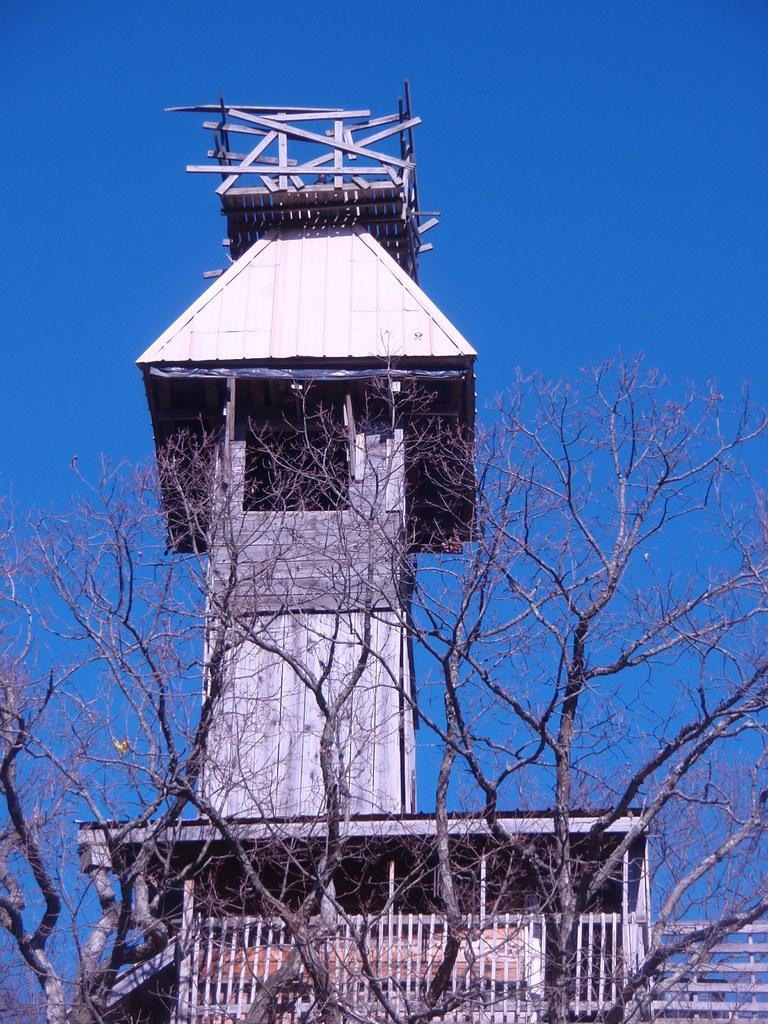Where was the image taken? The image was clicked outside. What can be seen in the middle of the image? There are trees and a house-like structure in the middle of the image. What is the material used to build the house-like structure? The house-like structure is built with wood. What is visible at the top of the image? There is sky visible at the top of the image. What type of cactus can be seen in the image? There is no cactus present in the image. What pet is visible in the image? There is no pet visible in the image. 